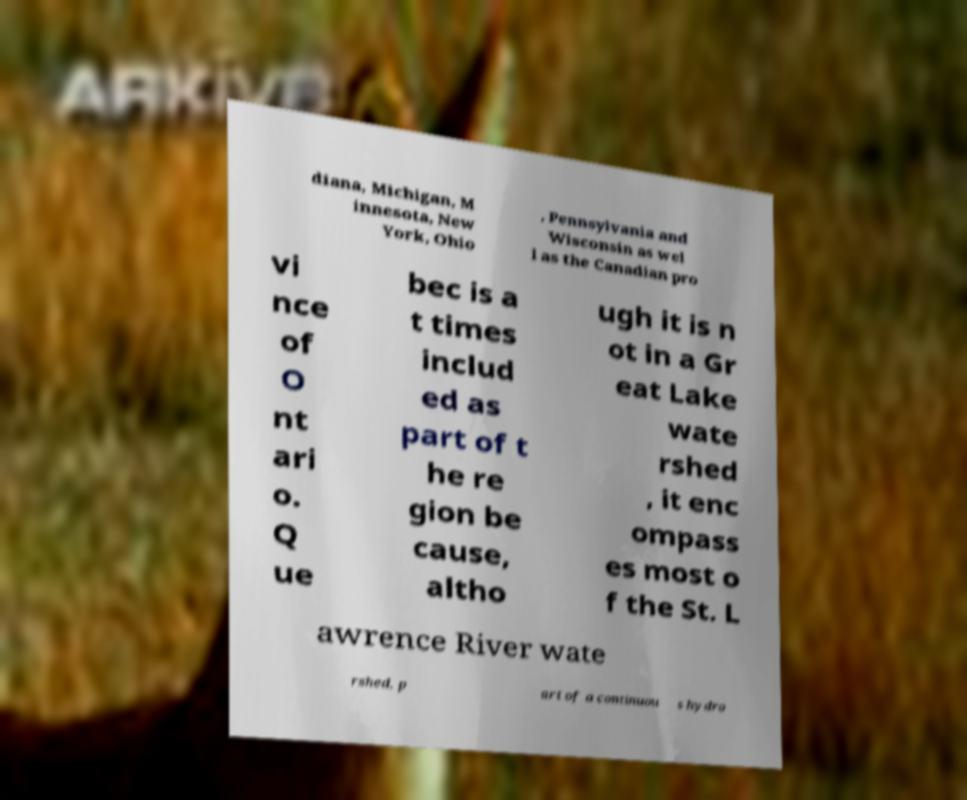Can you read and provide the text displayed in the image?This photo seems to have some interesting text. Can you extract and type it out for me? diana, Michigan, M innesota, New York, Ohio , Pennsylvania and Wisconsin as wel l as the Canadian pro vi nce of O nt ari o. Q ue bec is a t times includ ed as part of t he re gion be cause, altho ugh it is n ot in a Gr eat Lake wate rshed , it enc ompass es most o f the St. L awrence River wate rshed, p art of a continuou s hydro 